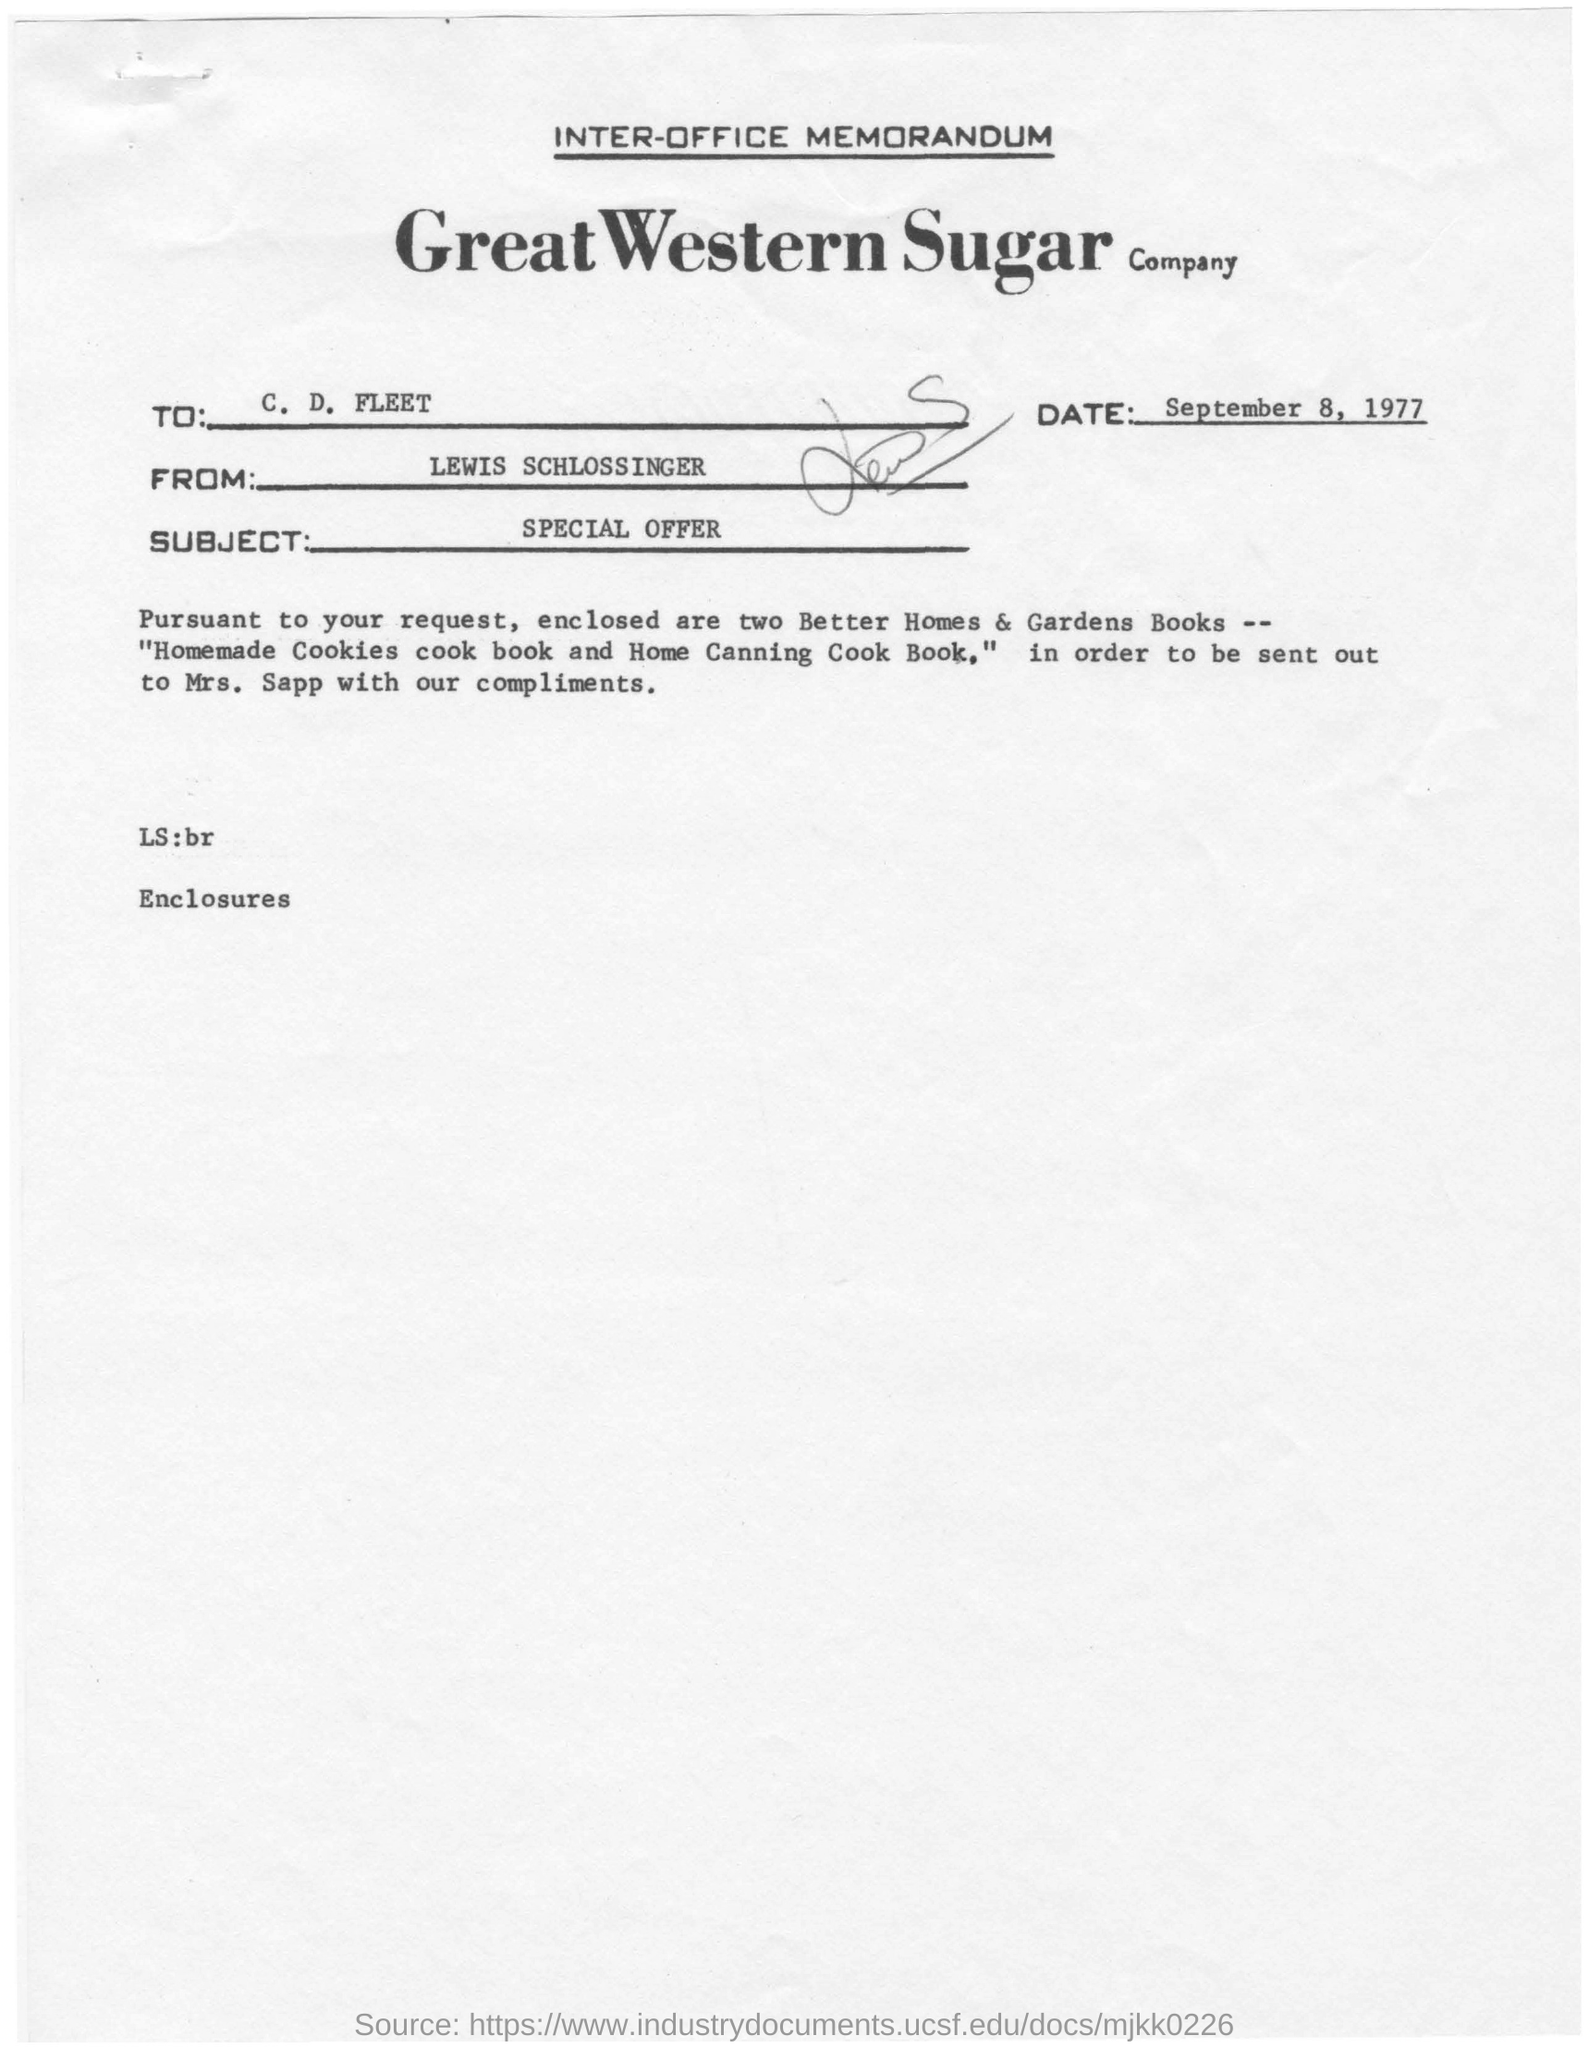Point out several critical features in this image. This document is an Inter-Office Memorandum. The subject line of the document reads "SPECIAL OFFER. The recipient is C. D. Fleet. The Company Name is the Great Western Sugar Company. The sender's name is Lewis Schlosser. 